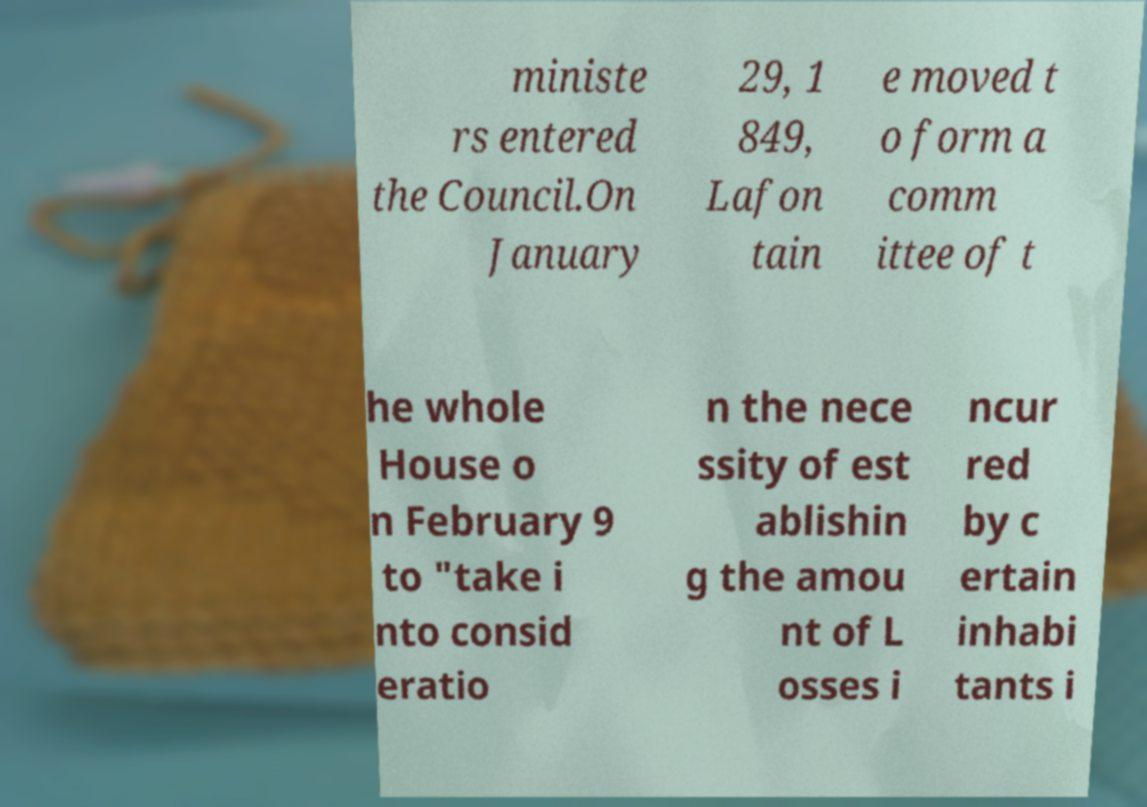For documentation purposes, I need the text within this image transcribed. Could you provide that? ministe rs entered the Council.On January 29, 1 849, Lafon tain e moved t o form a comm ittee of t he whole House o n February 9 to "take i nto consid eratio n the nece ssity of est ablishin g the amou nt of L osses i ncur red by c ertain inhabi tants i 